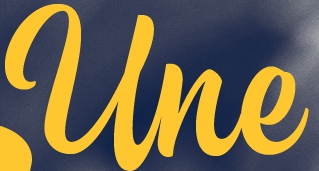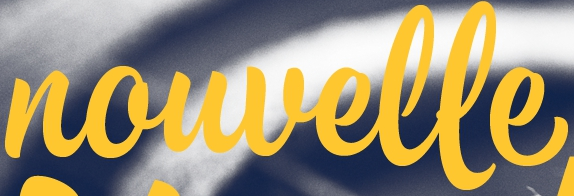What words are shown in these images in order, separated by a semicolon? Une; nouvelle 